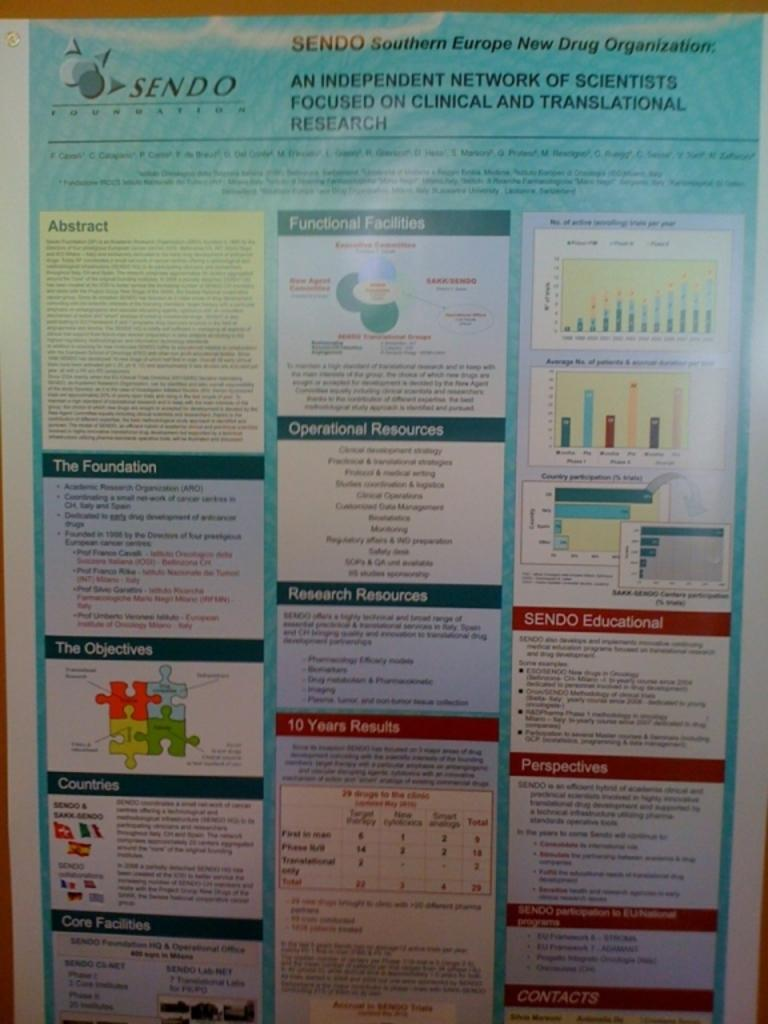<image>
Share a concise interpretation of the image provided. An informational display of various items put fourth by the Southern Europe New Drug Organization. 